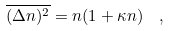Convert formula to latex. <formula><loc_0><loc_0><loc_500><loc_500>\overline { ( \Delta n ) ^ { 2 } } = n ( 1 + \kappa n ) \ \ ,</formula> 